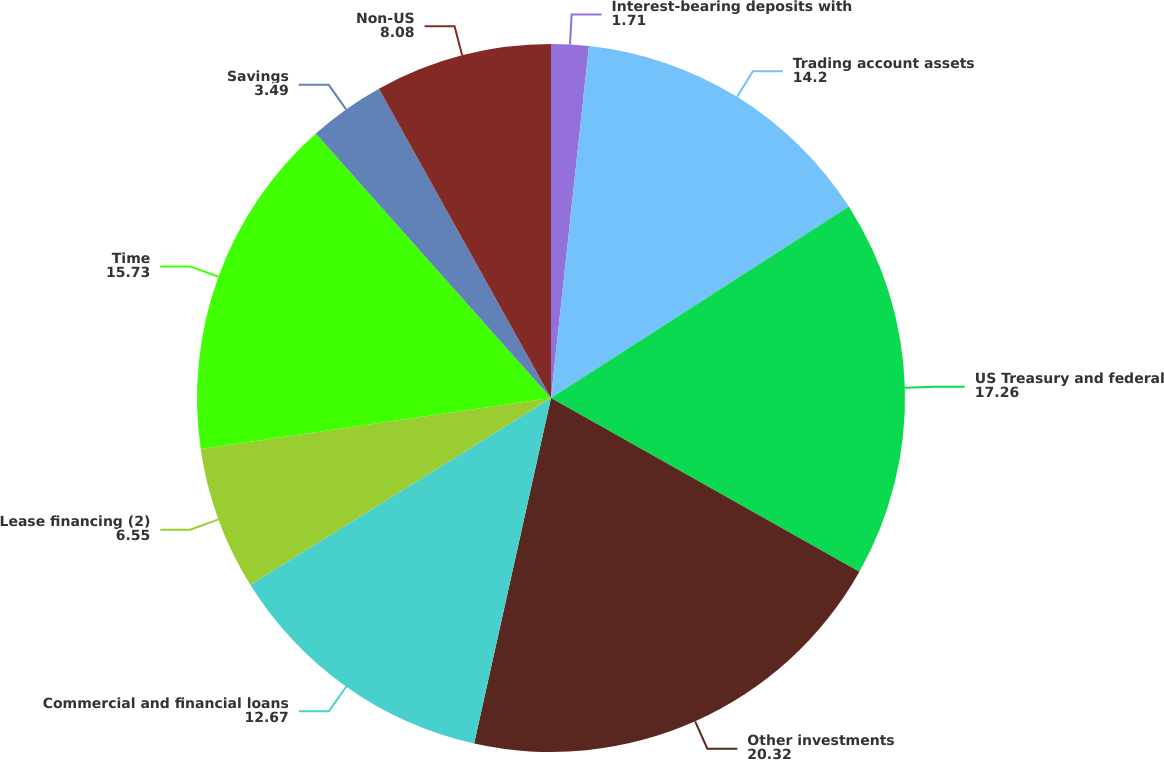<chart> <loc_0><loc_0><loc_500><loc_500><pie_chart><fcel>Interest-bearing deposits with<fcel>Trading account assets<fcel>US Treasury and federal<fcel>Other investments<fcel>Commercial and financial loans<fcel>Lease financing (2)<fcel>Time<fcel>Savings<fcel>Non-US<nl><fcel>1.71%<fcel>14.2%<fcel>17.26%<fcel>20.32%<fcel>12.67%<fcel>6.55%<fcel>15.73%<fcel>3.49%<fcel>8.08%<nl></chart> 